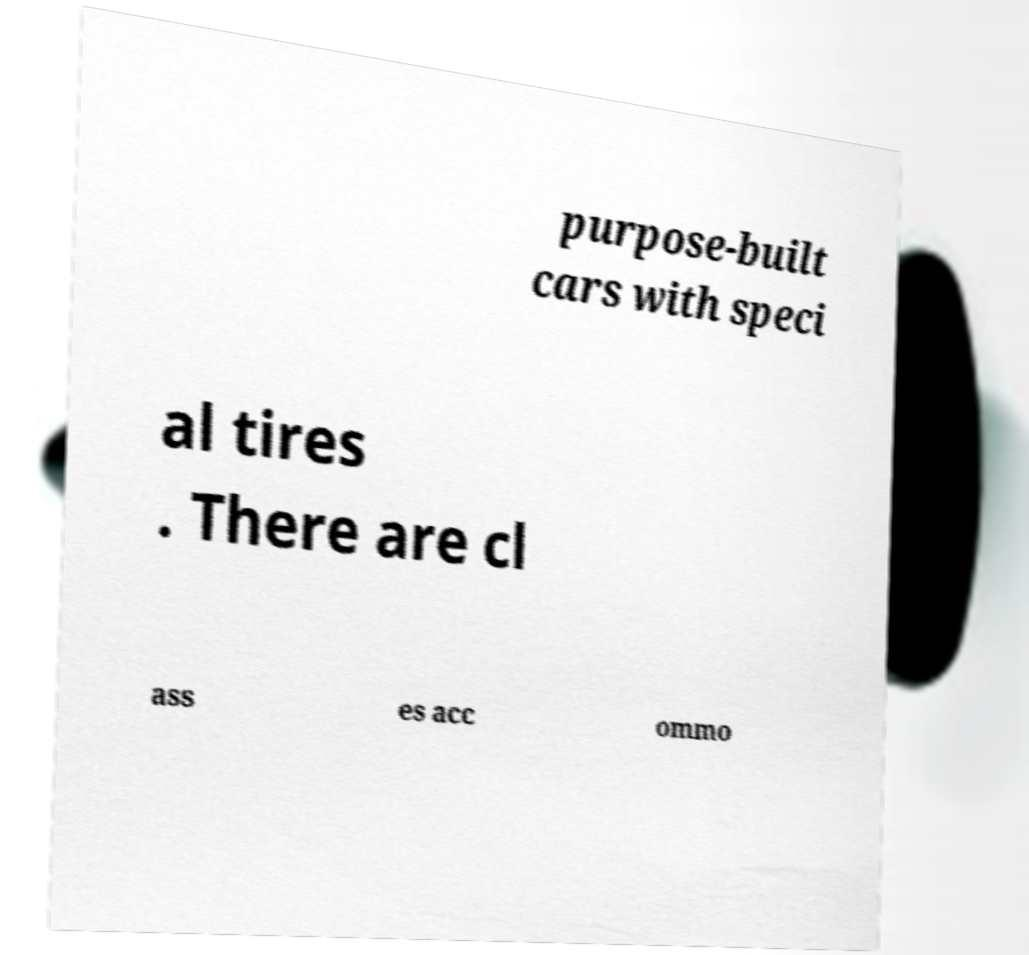Could you assist in decoding the text presented in this image and type it out clearly? purpose-built cars with speci al tires . There are cl ass es acc ommo 